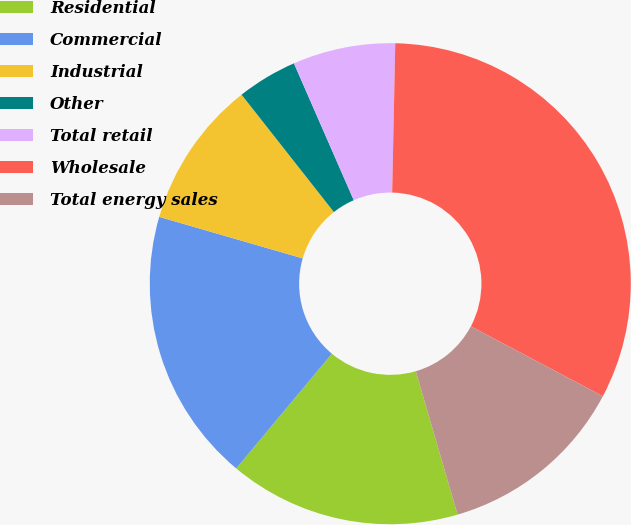Convert chart. <chart><loc_0><loc_0><loc_500><loc_500><pie_chart><fcel>Residential<fcel>Commercial<fcel>Industrial<fcel>Other<fcel>Total retail<fcel>Wholesale<fcel>Total energy sales<nl><fcel>15.58%<fcel>18.42%<fcel>9.91%<fcel>4.05%<fcel>6.89%<fcel>32.42%<fcel>12.74%<nl></chart> 